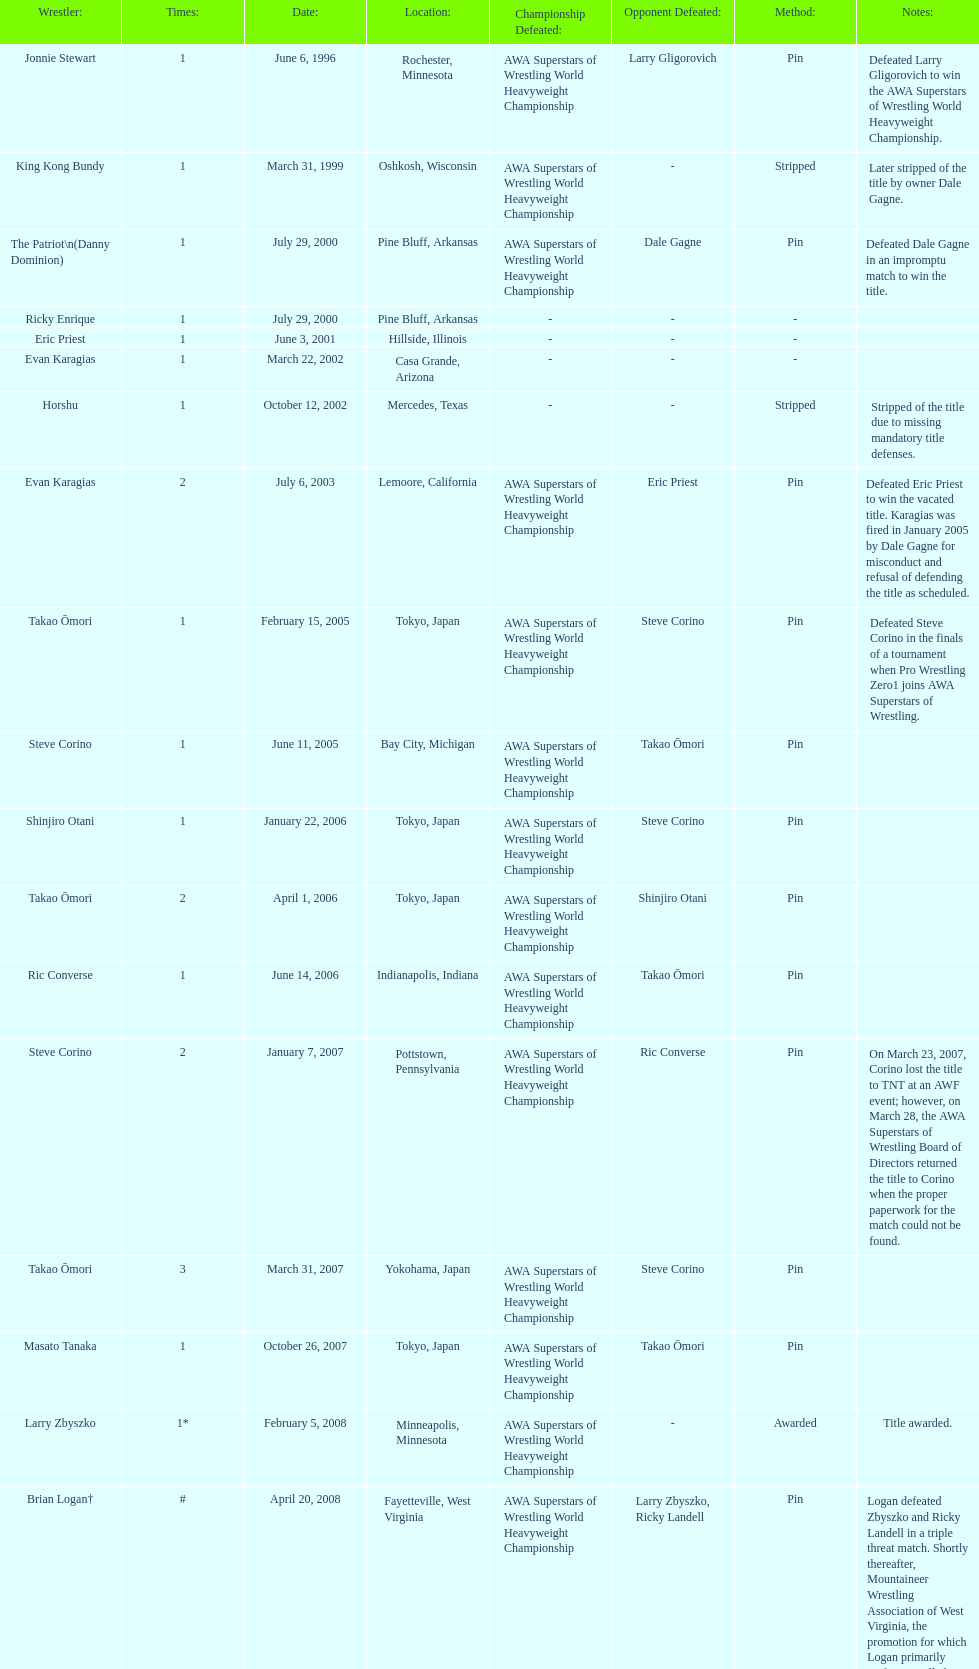When did steve corino win his first wsl title? June 11, 2005. 